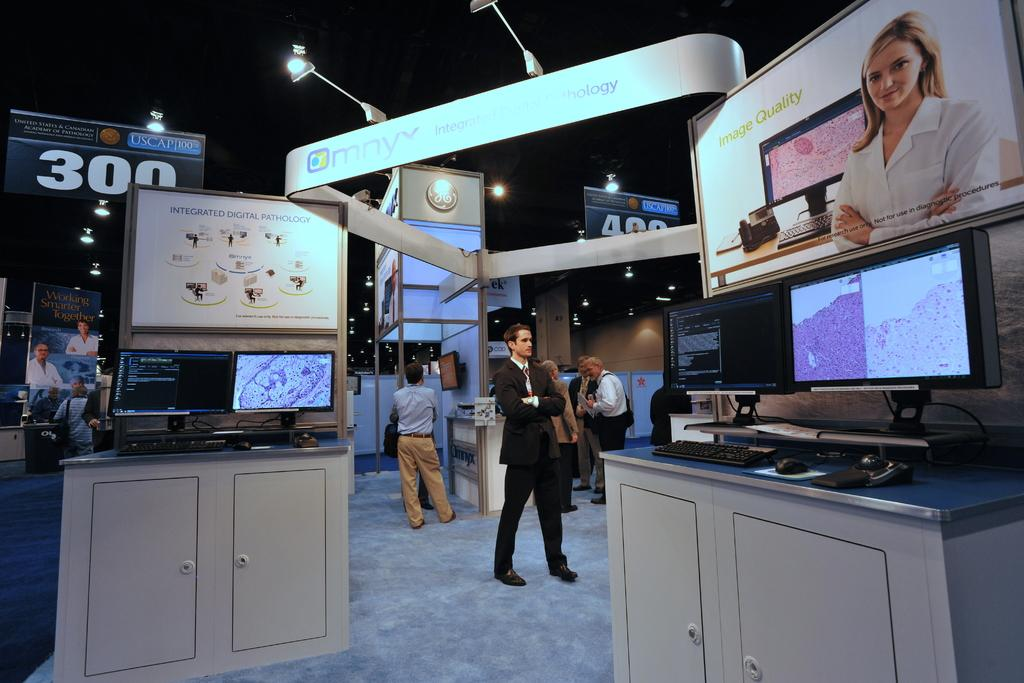<image>
Create a compact narrative representing the image presented. People at an imaging booth at a conference center for USCAP. 